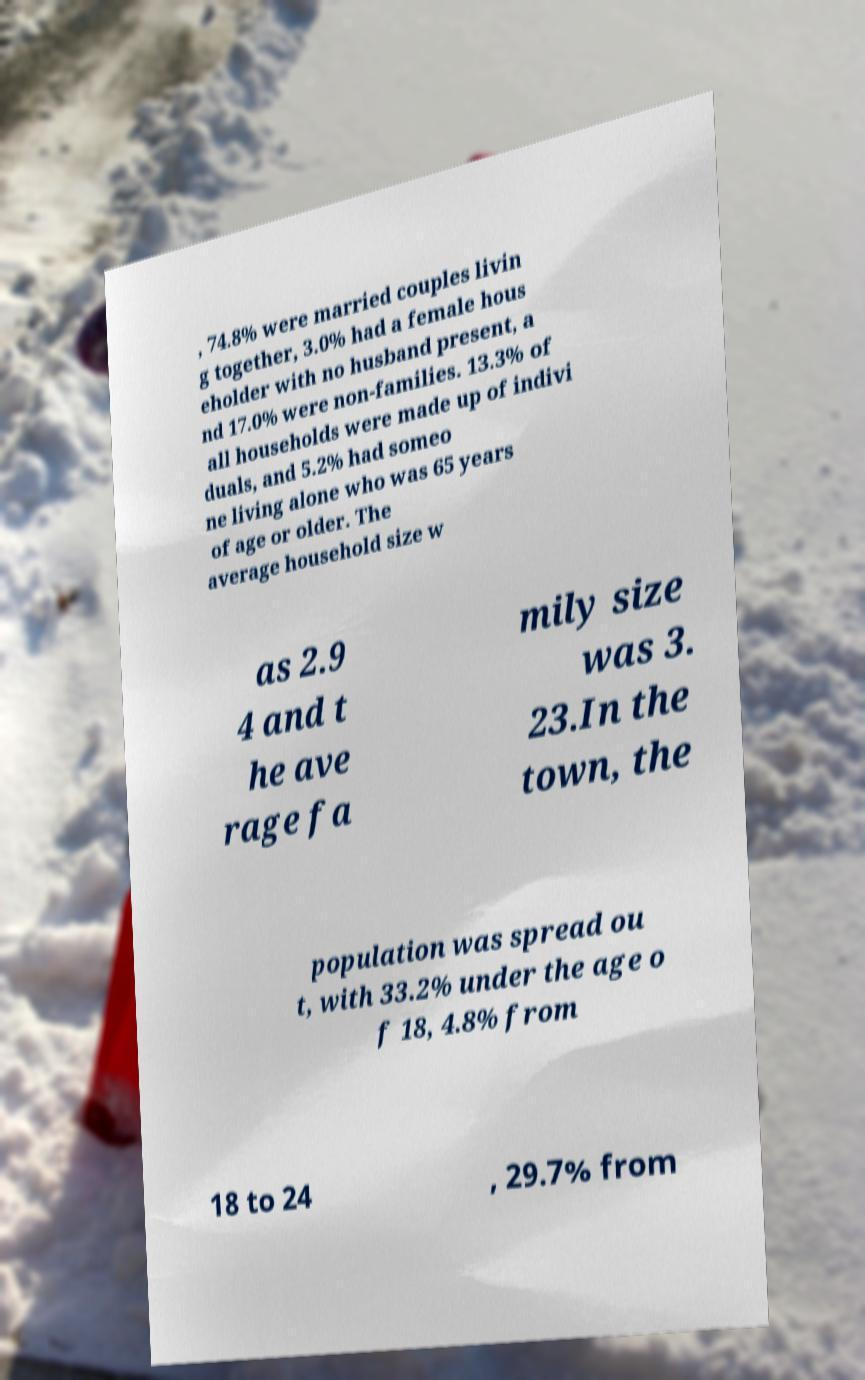Could you extract and type out the text from this image? , 74.8% were married couples livin g together, 3.0% had a female hous eholder with no husband present, a nd 17.0% were non-families. 13.3% of all households were made up of indivi duals, and 5.2% had someo ne living alone who was 65 years of age or older. The average household size w as 2.9 4 and t he ave rage fa mily size was 3. 23.In the town, the population was spread ou t, with 33.2% under the age o f 18, 4.8% from 18 to 24 , 29.7% from 